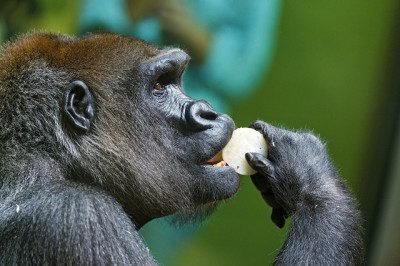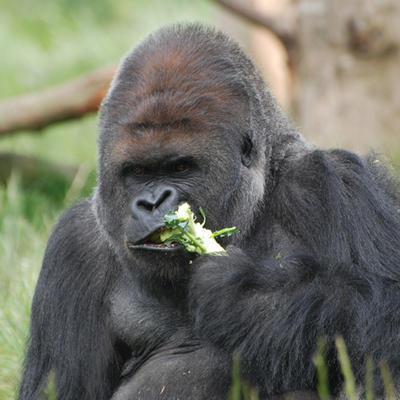The first image is the image on the left, the second image is the image on the right. Examine the images to the left and right. Is the description "The right image includes twice the number of gorillas as the left image." accurate? Answer yes or no. No. The first image is the image on the left, the second image is the image on the right. Evaluate the accuracy of this statement regarding the images: "At least one of the animals in the group is not eating.". Is it true? Answer yes or no. No. 